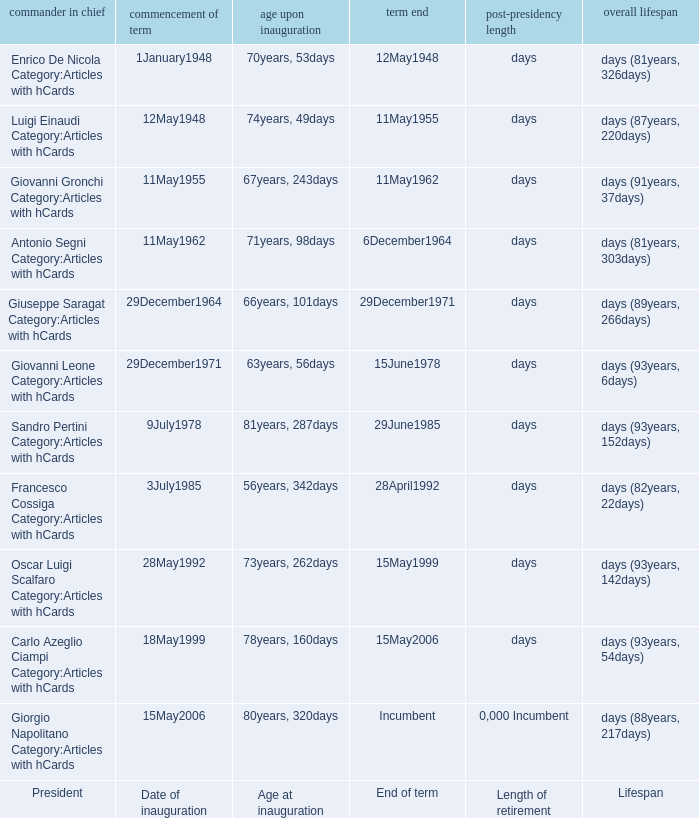What is the End of term of the President with an Age at inauguration of 78years, 160days? 15May2006. 